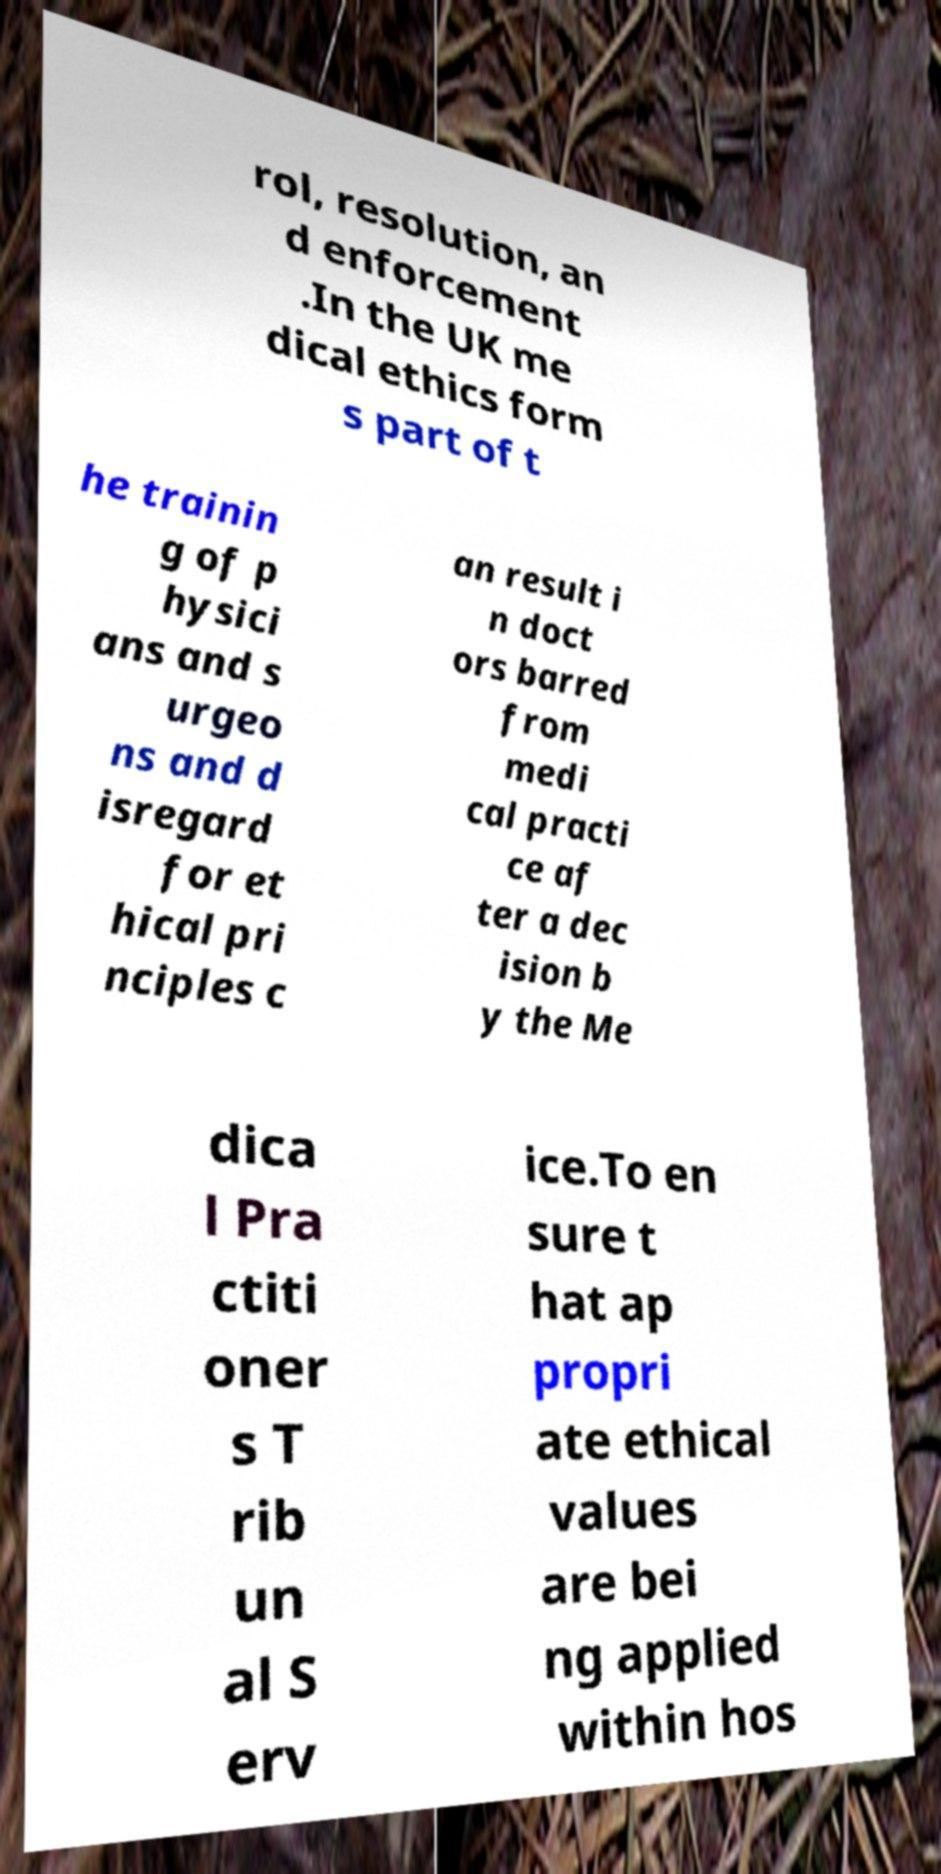For documentation purposes, I need the text within this image transcribed. Could you provide that? rol, resolution, an d enforcement .In the UK me dical ethics form s part of t he trainin g of p hysici ans and s urgeo ns and d isregard for et hical pri nciples c an result i n doct ors barred from medi cal practi ce af ter a dec ision b y the Me dica l Pra ctiti oner s T rib un al S erv ice.To en sure t hat ap propri ate ethical values are bei ng applied within hos 